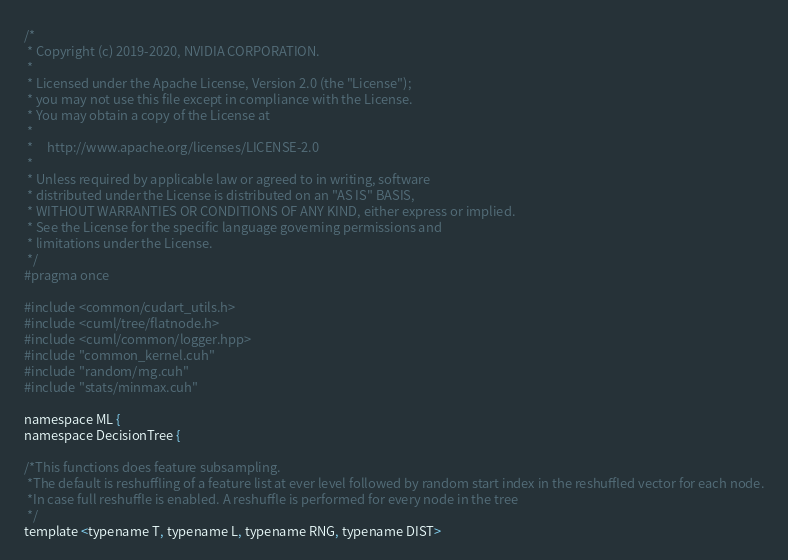Convert code to text. <code><loc_0><loc_0><loc_500><loc_500><_Cuda_>/*
 * Copyright (c) 2019-2020, NVIDIA CORPORATION.
 *
 * Licensed under the Apache License, Version 2.0 (the "License");
 * you may not use this file except in compliance with the License.
 * You may obtain a copy of the License at
 *
 *     http://www.apache.org/licenses/LICENSE-2.0
 *
 * Unless required by applicable law or agreed to in writing, software
 * distributed under the License is distributed on an "AS IS" BASIS,
 * WITHOUT WARRANTIES OR CONDITIONS OF ANY KIND, either express or implied.
 * See the License for the specific language governing permissions and
 * limitations under the License.
 */
#pragma once

#include <common/cudart_utils.h>
#include <cuml/tree/flatnode.h>
#include <cuml/common/logger.hpp>
#include "common_kernel.cuh"
#include "random/rng.cuh"
#include "stats/minmax.cuh"

namespace ML {
namespace DecisionTree {

/*This functions does feature subsampling.
 *The default is reshuffling of a feature list at ever level followed by random start index in the reshuffled vector for each node.
 *In case full reshuffle is enabled. A reshuffle is performed for every node in the tree
 */
template <typename T, typename L, typename RNG, typename DIST></code> 